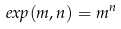<formula> <loc_0><loc_0><loc_500><loc_500>e x p ( m , n ) = m ^ { n }</formula> 